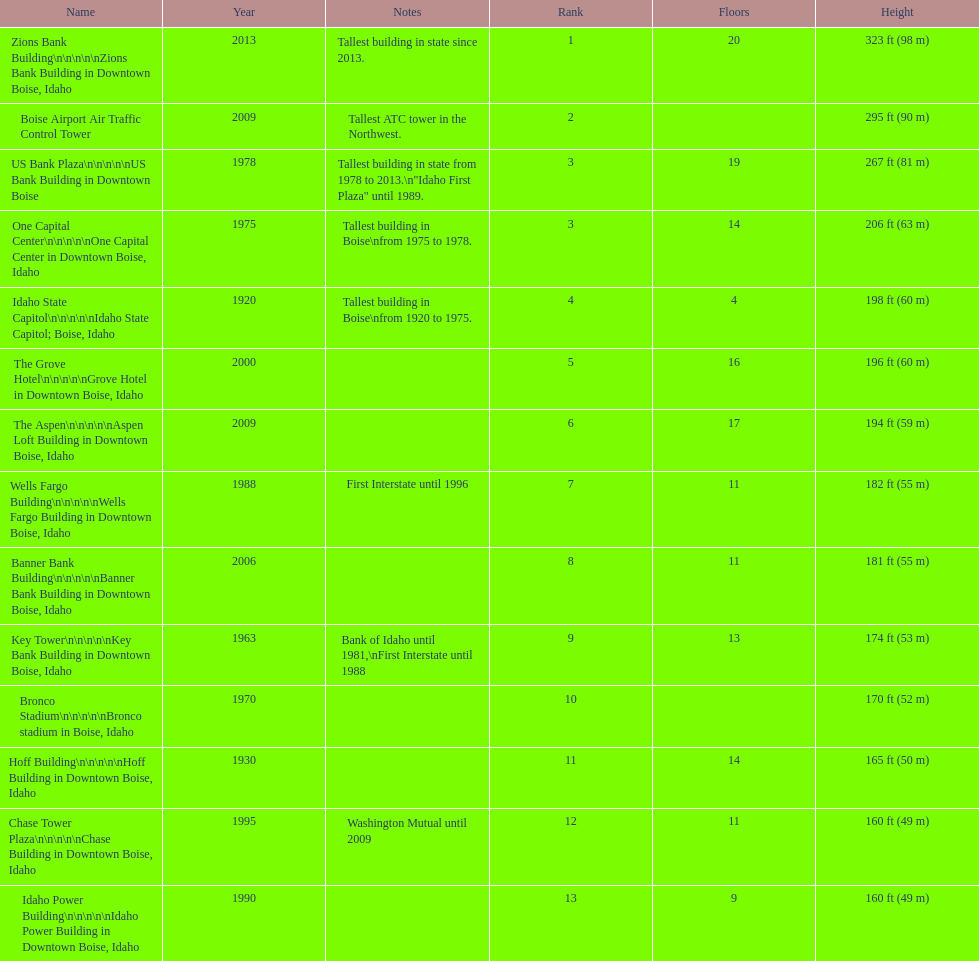What is the name of the building listed after idaho state capitol? The Grove Hotel. 